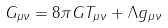Convert formula to latex. <formula><loc_0><loc_0><loc_500><loc_500>G _ { \mu \nu } = 8 \pi G T _ { \mu \nu } + \Lambda g _ { \mu \nu }</formula> 